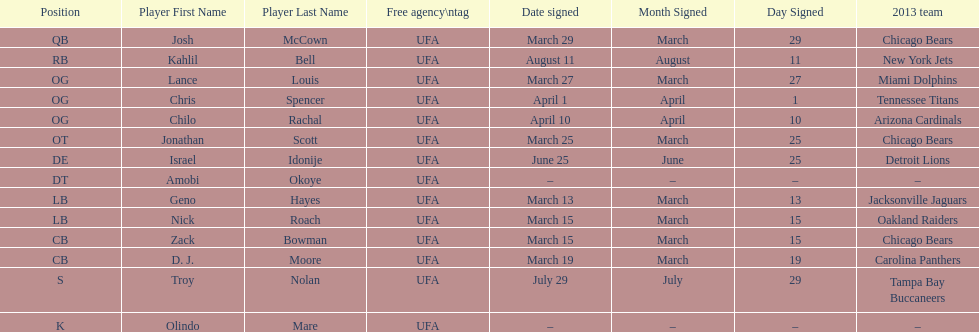Who was the previous player signed before troy nolan? Israel Idonije. 